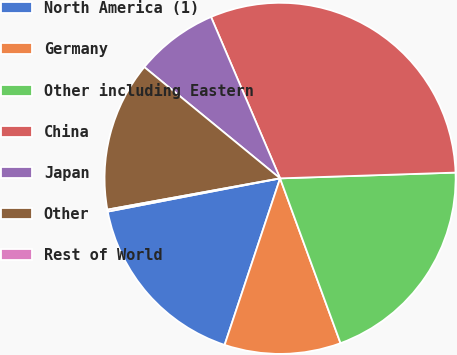Convert chart to OTSL. <chart><loc_0><loc_0><loc_500><loc_500><pie_chart><fcel>North America (1)<fcel>Germany<fcel>Other including Eastern<fcel>China<fcel>Japan<fcel>Other<fcel>Rest of World<nl><fcel>16.85%<fcel>10.71%<fcel>19.93%<fcel>30.91%<fcel>7.64%<fcel>13.78%<fcel>0.18%<nl></chart> 